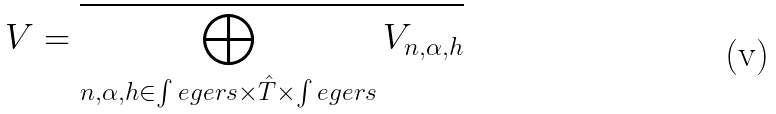Convert formula to latex. <formula><loc_0><loc_0><loc_500><loc_500>V = \overline { \bigoplus _ { n , \alpha , h \in \int e g e r s \times \hat { T } \times \int e g e r s } V _ { n , \alpha , h } }</formula> 